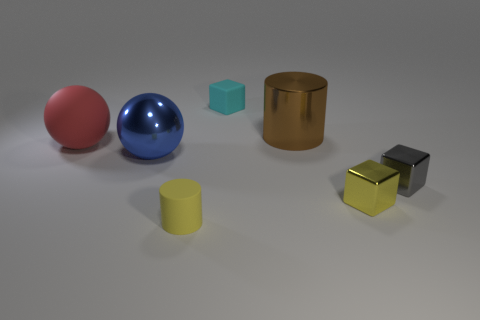Add 2 small gray shiny cubes. How many objects exist? 9 Subtract all cylinders. How many objects are left? 5 Add 1 tiny yellow cylinders. How many tiny yellow cylinders are left? 2 Add 1 green metal cylinders. How many green metal cylinders exist? 1 Subtract 0 green balls. How many objects are left? 7 Subtract all small blue things. Subtract all tiny gray cubes. How many objects are left? 6 